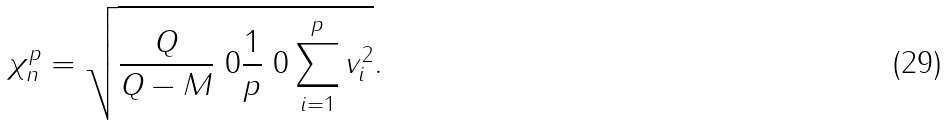<formula> <loc_0><loc_0><loc_500><loc_500>\chi _ { n } ^ { p } = \sqrt { \frac { Q } { Q - M } \ 0 \frac { 1 } { p } \ 0 \sum _ { i = 1 } ^ { p } v _ { i } ^ { 2 } } .</formula> 